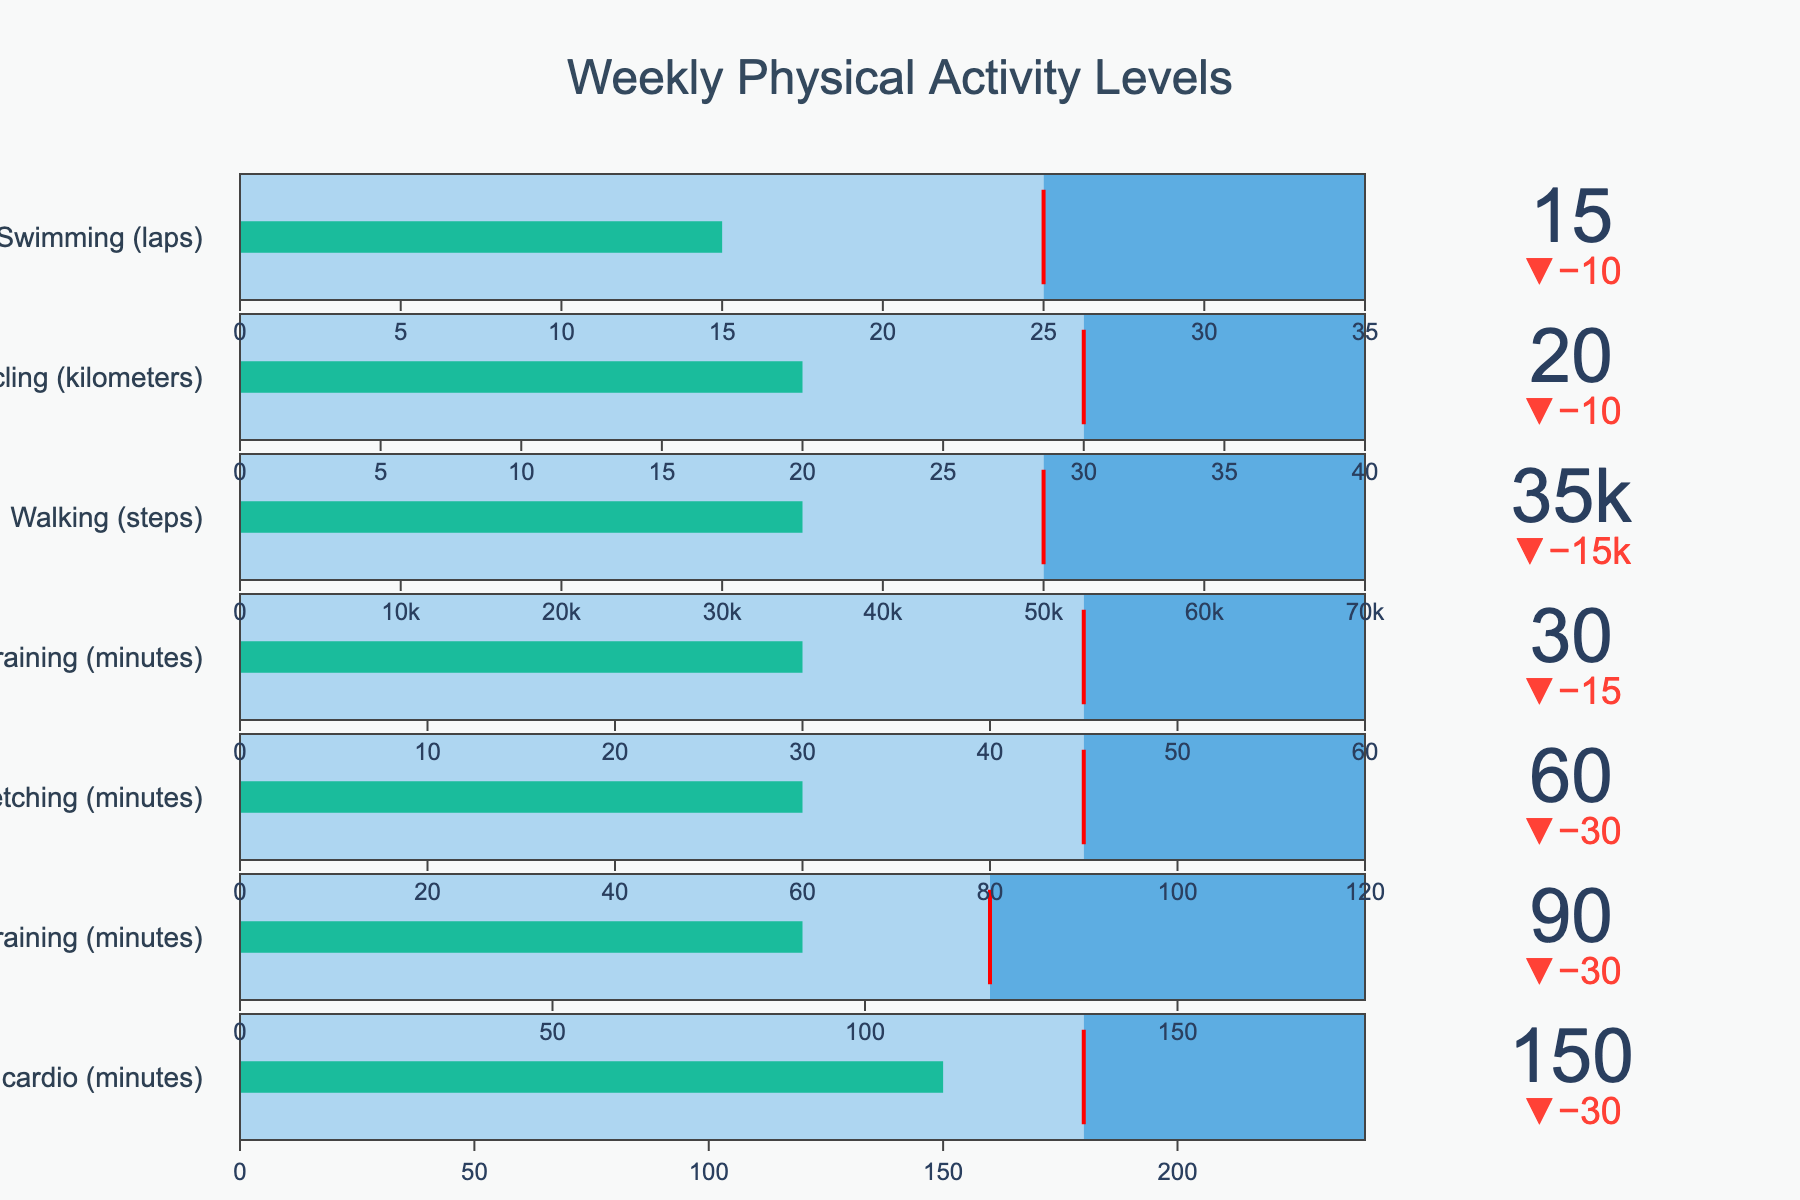What is the title of the figure? The title of the figure is displayed at the top of the chart, and it provides an overview of what the chart represents. It reads, "Weekly Physical Activity Levels."
Answer: Weekly Physical Activity Levels What activity has the highest target value? By looking at the chart, you can see that the target values are displayed as thresholds on each bullet chart. The activity with the highest target value is "Walking (steps)" with 50,000 steps.
Answer: Walking (steps) What is the difference between the actual and target values for High-intensity interval training (minutes)? The actual value for High-intensity interval training (minutes) is 30, and the target value is 45. The difference is calculated as 45 - 30 = 15.
Answer: 15 Which physical activity is closest to its target value? To determine this, you need to look at the delta values which are visually represented on each bullet chart. "Moderate cardio (minutes)" is closest to its target with an actual value of 150 and a target of 180, making it 30 minutes below target.
Answer: Moderate cardio (minutes) Which activity has the highest maximum value? By examining the chart, each activity has a bar that reaches up to its maximum value. "Walking (steps)" has the highest maximum value among all activities with 70,000 steps.
Answer: Walking (steps) Which activity's actual value exceeds its target value? This can be observed by checking if the actual value on the bullet chart surpasses the threshold line. For "Cycling (kilometers)," the actual value is 20, which does not exceed the target of 30. All other activities' actual values are also below their target values. Therefore, none of the activities exceed their target values.
Answer: None How much more walking (in steps) is needed to reach the target? The current actual value for walking is 35,000 steps and the target value is 50,000 steps. The difference is 50,000 - 35,000 = 15,000 steps.
Answer: 15,000 What is the sum of the actual values for yoga/stretching and cycling? The actual value for yoga/stretching is 60 minutes, and for cycling, it is 20 kilometers. Adding these two values gives 60 + 20 = 80.
Answer: 80 Which activity has the smallest difference between the maximum and target values? You need to subtract the target value from the maximum value for each activity. The difference for Moderate cardio (minutes) is 240-180=60, Strength training is 180-120=60, Yoga/stretching is 120-90=30, High-intensity interval training is 60-45=15, Walking is 70,000-50,000=20,000, Cycling is 40-30=10, Swimming is 35-25=10. Thus, Cycling and Swimming both have the smallest difference of 10 units.
Answer: Cycling and Swimming What color represents the progress bar in the bullet chart? The progress bar that shows the actual value in the bullet chart is colored green. This can be observed directly in the visual representation of each chart.
Answer: Green 